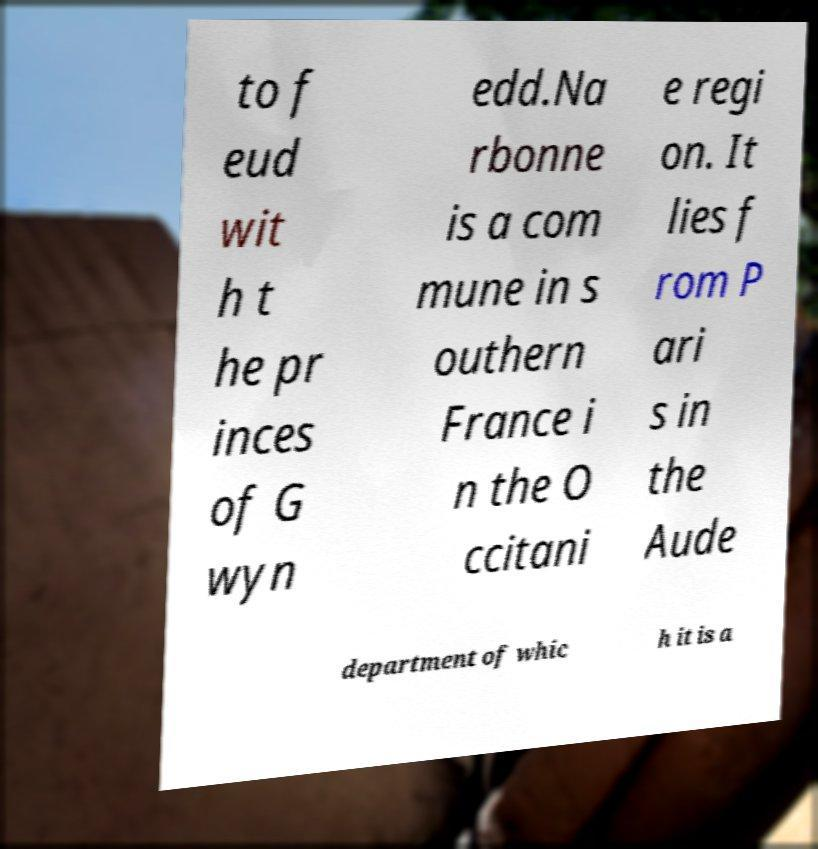Please read and relay the text visible in this image. What does it say? to f eud wit h t he pr inces of G wyn edd.Na rbonne is a com mune in s outhern France i n the O ccitani e regi on. It lies f rom P ari s in the Aude department of whic h it is a 